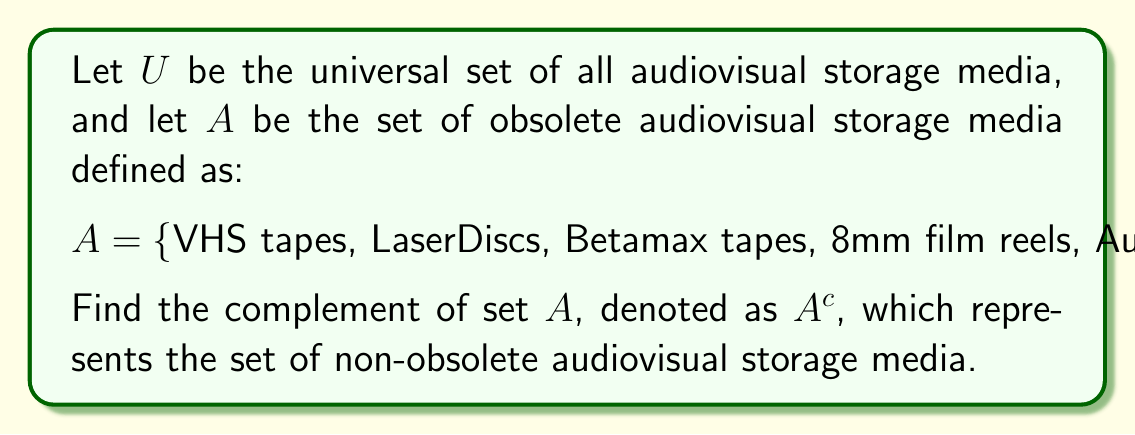Can you answer this question? To solve this problem, we need to understand the concept of set complement and apply it to the given context of audiovisual storage media.

1) The complement of a set $A$, denoted as $A^c$, is defined as all elements in the universal set $U$ that are not in $A$. Mathematically, this is expressed as:

   $A^c = \{x \in U : x \notin A\}$

2) In this case, $A$ represents obsolete audiovisual storage media. Therefore, $A^c$ will contain all audiovisual storage media that are not considered obsolete.

3) To find $A^c$, we need to consider modern and currently used audiovisual storage media. These may include:

   - Blu-ray discs
   - DVDs
   - SD cards
   - USB flash drives
   - External hard drives
   - Cloud storage
   - Digital cinema packages (DCPs)

4) It's important to note that the universal set $U$ is not explicitly defined, so $A^c$ could potentially include other media types not listed here.

5) The complement set $A^c$ is theoretically infinite, as it includes all possible current and future audiovisual storage media that are not in set $A$.

6) In set theory notation, we can express $A^c$ as:

   $A^c = \{x \in U : x \text{ is a non-obsolete audiovisual storage medium}\}$

This representation allows for the inclusion of all current and future non-obsolete storage media without explicitly listing them all.
Answer: $A^c = \{x \in U : x \text{ is a non-obsolete audiovisual storage medium}\}$

Examples include: Blu-ray discs, DVDs, SD cards, USB flash drives, external hard drives, cloud storage, digital cinema packages (DCPs), and any other current or future non-obsolete audiovisual storage media. 